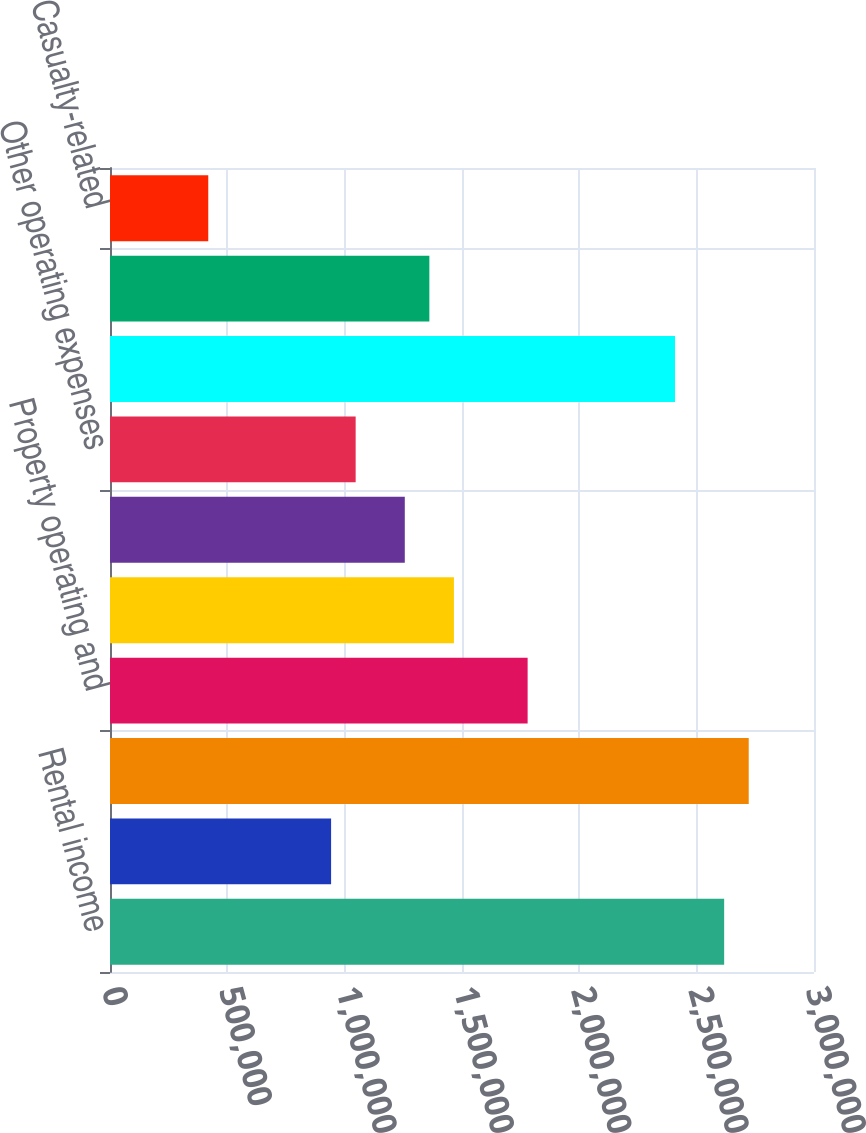Convert chart. <chart><loc_0><loc_0><loc_500><loc_500><bar_chart><fcel>Rental income<fcel>Joint venture management and<fcel>Total revenues<fcel>Property operating and<fcel>Real estate taxes and<fcel>Property management<fcel>Other operating expenses<fcel>Real estate depreciation and<fcel>General and administrative<fcel>Casualty-related<nl><fcel>2.61715e+06<fcel>942173<fcel>2.72183e+06<fcel>1.77966e+06<fcel>1.4656e+06<fcel>1.25623e+06<fcel>1.04686e+06<fcel>2.40777e+06<fcel>1.36092e+06<fcel>418744<nl></chart> 